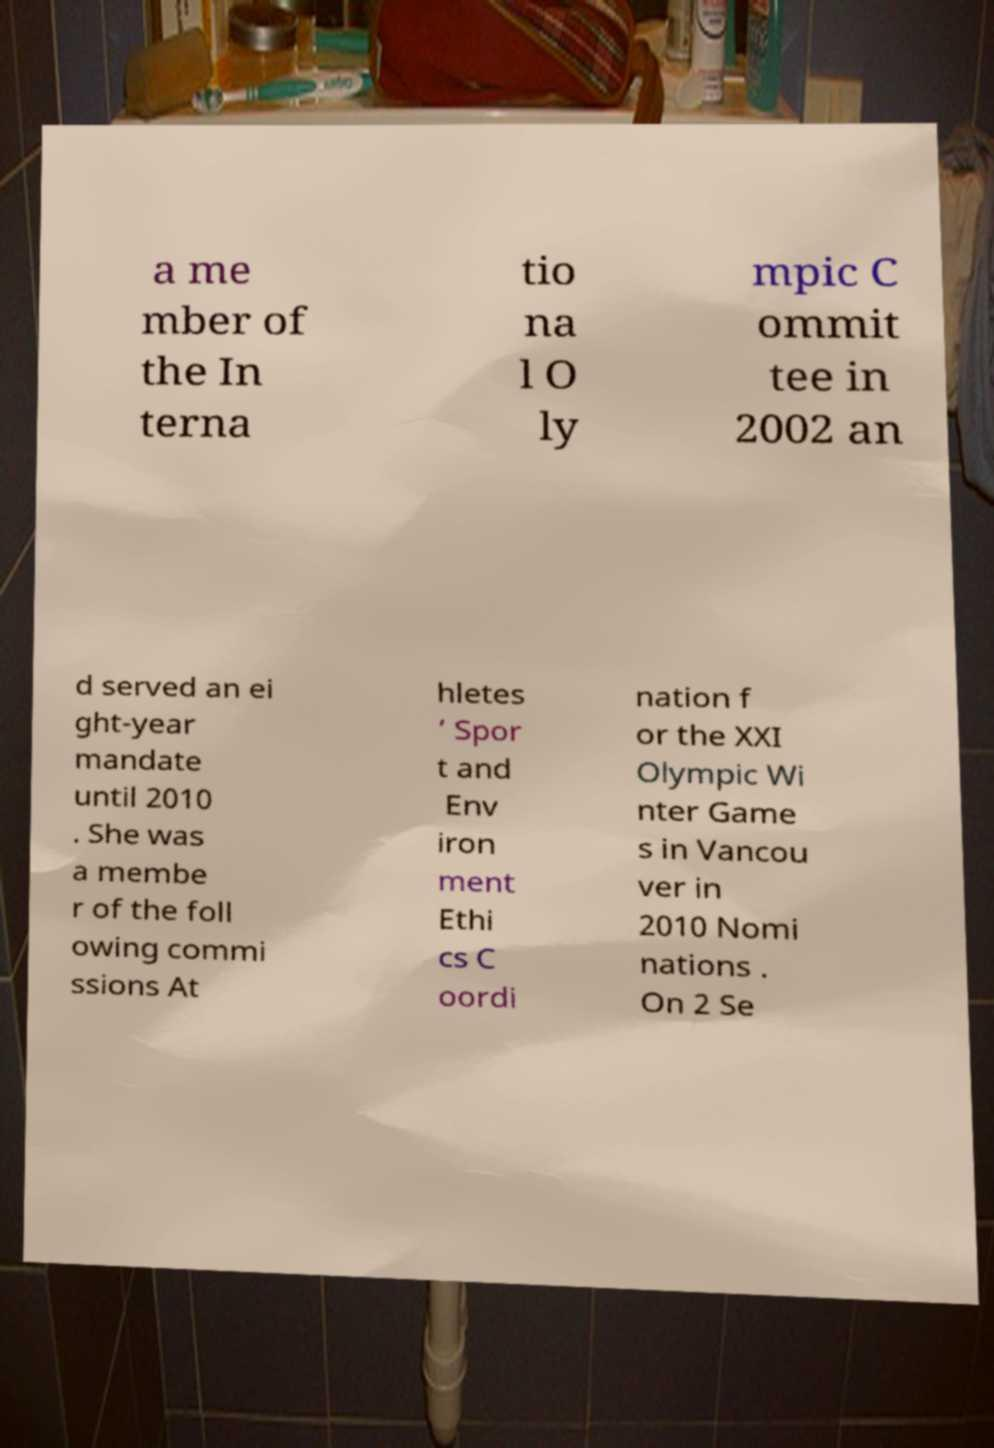I need the written content from this picture converted into text. Can you do that? a me mber of the In terna tio na l O ly mpic C ommit tee in 2002 an d served an ei ght-year mandate until 2010 . She was a membe r of the foll owing commi ssions At hletes ’ Spor t and Env iron ment Ethi cs C oordi nation f or the XXI Olympic Wi nter Game s in Vancou ver in 2010 Nomi nations . On 2 Se 